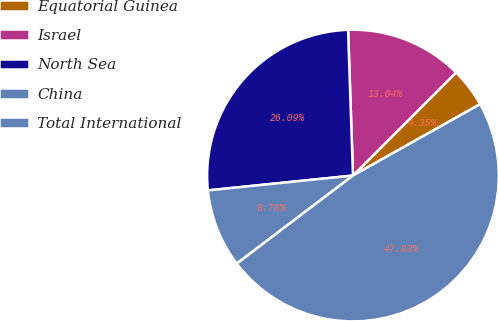Convert chart to OTSL. <chart><loc_0><loc_0><loc_500><loc_500><pie_chart><fcel>Equatorial Guinea<fcel>Israel<fcel>North Sea<fcel>China<fcel>Total International<nl><fcel>4.35%<fcel>13.04%<fcel>26.09%<fcel>8.7%<fcel>47.83%<nl></chart> 